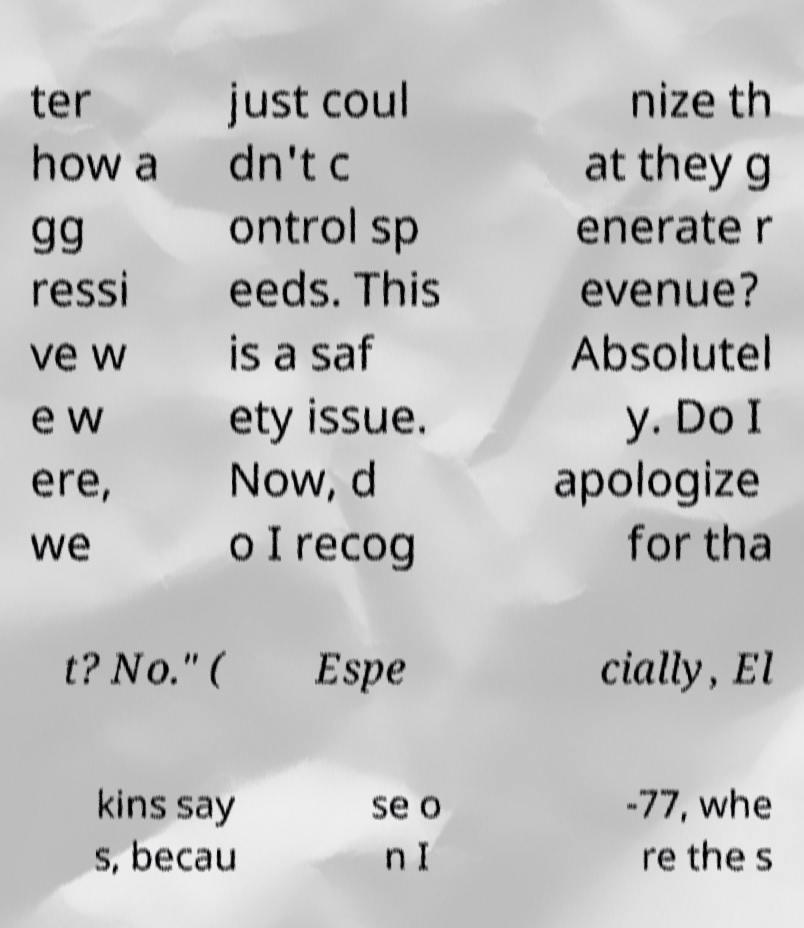Please identify and transcribe the text found in this image. ter how a gg ressi ve w e w ere, we just coul dn't c ontrol sp eeds. This is a saf ety issue. Now, d o I recog nize th at they g enerate r evenue? Absolutel y. Do I apologize for tha t? No." ( Espe cially, El kins say s, becau se o n I -77, whe re the s 